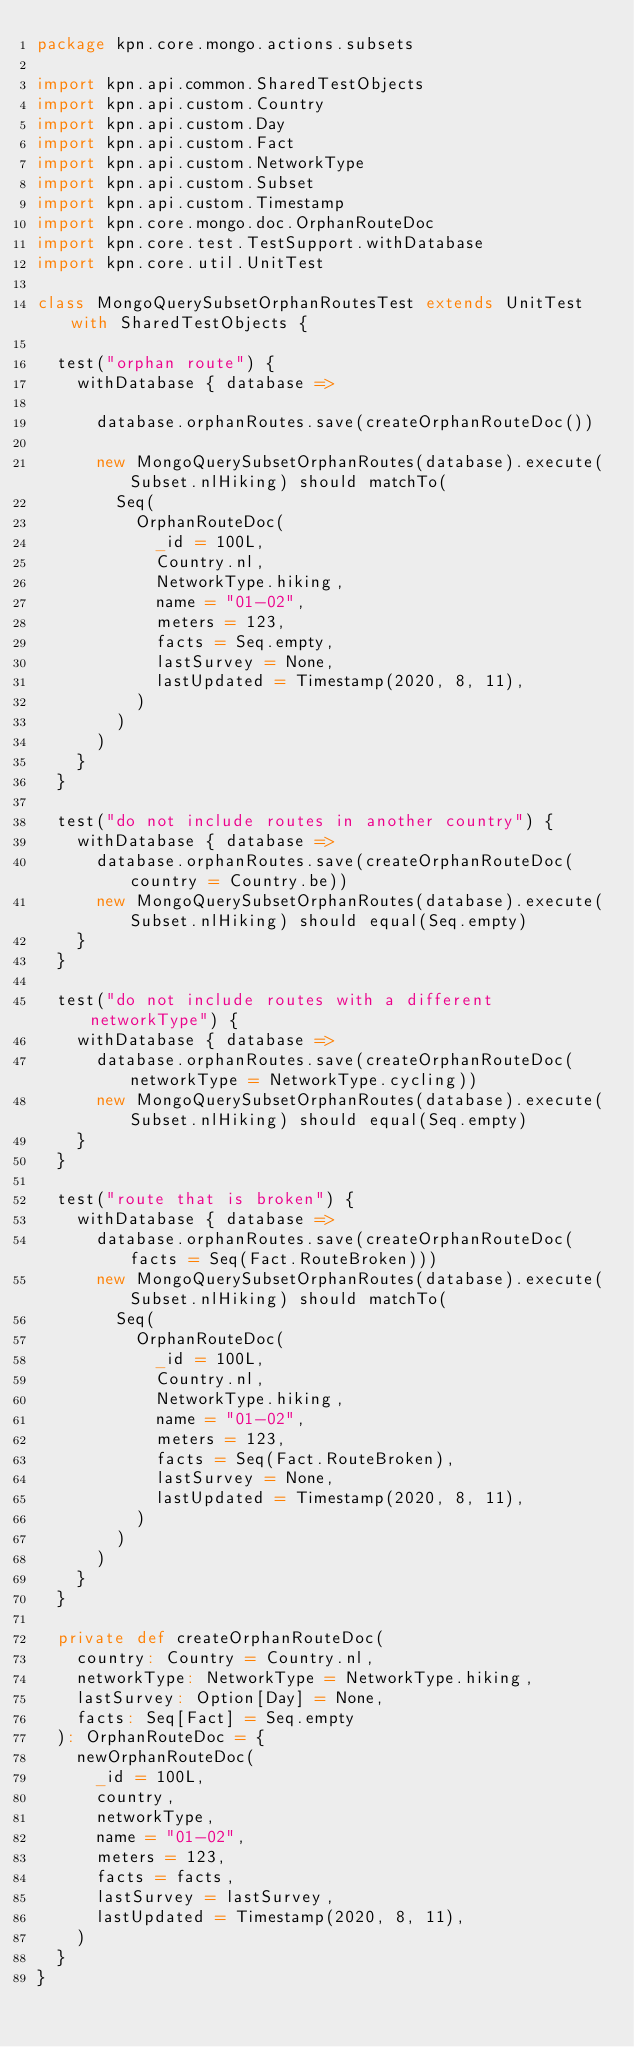<code> <loc_0><loc_0><loc_500><loc_500><_Scala_>package kpn.core.mongo.actions.subsets

import kpn.api.common.SharedTestObjects
import kpn.api.custom.Country
import kpn.api.custom.Day
import kpn.api.custom.Fact
import kpn.api.custom.NetworkType
import kpn.api.custom.Subset
import kpn.api.custom.Timestamp
import kpn.core.mongo.doc.OrphanRouteDoc
import kpn.core.test.TestSupport.withDatabase
import kpn.core.util.UnitTest

class MongoQuerySubsetOrphanRoutesTest extends UnitTest with SharedTestObjects {

  test("orphan route") {
    withDatabase { database =>

      database.orphanRoutes.save(createOrphanRouteDoc())

      new MongoQuerySubsetOrphanRoutes(database).execute(Subset.nlHiking) should matchTo(
        Seq(
          OrphanRouteDoc(
            _id = 100L,
            Country.nl,
            NetworkType.hiking,
            name = "01-02",
            meters = 123,
            facts = Seq.empty,
            lastSurvey = None,
            lastUpdated = Timestamp(2020, 8, 11),
          )
        )
      )
    }
  }

  test("do not include routes in another country") {
    withDatabase { database =>
      database.orphanRoutes.save(createOrphanRouteDoc(country = Country.be))
      new MongoQuerySubsetOrphanRoutes(database).execute(Subset.nlHiking) should equal(Seq.empty)
    }
  }

  test("do not include routes with a different networkType") {
    withDatabase { database =>
      database.orphanRoutes.save(createOrphanRouteDoc(networkType = NetworkType.cycling))
      new MongoQuerySubsetOrphanRoutes(database).execute(Subset.nlHiking) should equal(Seq.empty)
    }
  }

  test("route that is broken") {
    withDatabase { database =>
      database.orphanRoutes.save(createOrphanRouteDoc(facts = Seq(Fact.RouteBroken)))
      new MongoQuerySubsetOrphanRoutes(database).execute(Subset.nlHiking) should matchTo(
        Seq(
          OrphanRouteDoc(
            _id = 100L,
            Country.nl,
            NetworkType.hiking,
            name = "01-02",
            meters = 123,
            facts = Seq(Fact.RouteBroken),
            lastSurvey = None,
            lastUpdated = Timestamp(2020, 8, 11),
          )
        )
      )
    }
  }

  private def createOrphanRouteDoc(
    country: Country = Country.nl,
    networkType: NetworkType = NetworkType.hiking,
    lastSurvey: Option[Day] = None,
    facts: Seq[Fact] = Seq.empty
  ): OrphanRouteDoc = {
    newOrphanRouteDoc(
      _id = 100L,
      country,
      networkType,
      name = "01-02",
      meters = 123,
      facts = facts,
      lastSurvey = lastSurvey,
      lastUpdated = Timestamp(2020, 8, 11),
    )
  }
}
</code> 